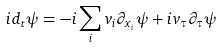<formula> <loc_0><loc_0><loc_500><loc_500>i d _ { t } \psi = - i \sum _ { i } v _ { i } \partial _ { x _ { i } } \psi + i v _ { \tau } \partial _ { \tau } \psi</formula> 